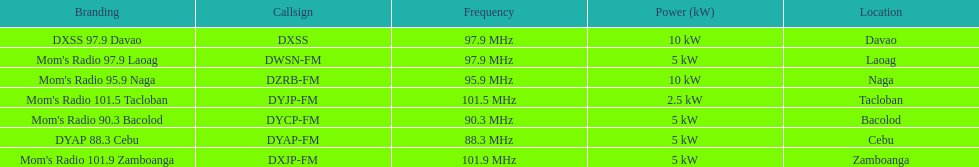Can you give me this table as a dict? {'header': ['Branding', 'Callsign', 'Frequency', 'Power (kW)', 'Location'], 'rows': [['DXSS 97.9 Davao', 'DXSS', '97.9\xa0MHz', '10\xa0kW', 'Davao'], ["Mom's Radio 97.9 Laoag", 'DWSN-FM', '97.9\xa0MHz', '5\xa0kW', 'Laoag'], ["Mom's Radio 95.9 Naga", 'DZRB-FM', '95.9\xa0MHz', '10\xa0kW', 'Naga'], ["Mom's Radio 101.5 Tacloban", 'DYJP-FM', '101.5\xa0MHz', '2.5\xa0kW', 'Tacloban'], ["Mom's Radio 90.3 Bacolod", 'DYCP-FM', '90.3\xa0MHz', '5\xa0kW', 'Bacolod'], ['DYAP 88.3 Cebu', 'DYAP-FM', '88.3\xa0MHz', '5\xa0kW', 'Cebu'], ["Mom's Radio 101.9 Zamboanga", 'DXJP-FM', '101.9\xa0MHz', '5\xa0kW', 'Zamboanga']]} Which of these stations broadcasts with the least power? Mom's Radio 101.5 Tacloban. 